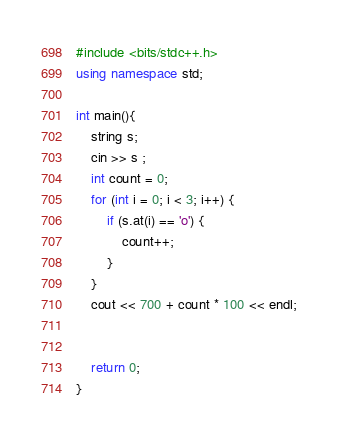Convert code to text. <code><loc_0><loc_0><loc_500><loc_500><_C++_>#include <bits/stdc++.h>
using namespace std;

int main(){
    string s;
    cin >> s ;
    int count = 0;
    for (int i = 0; i < 3; i++) {
        if (s.at(i) == 'o') {
            count++;
        }
    }
    cout << 700 + count * 100 << endl;
    
    
    return 0;
}
</code> 